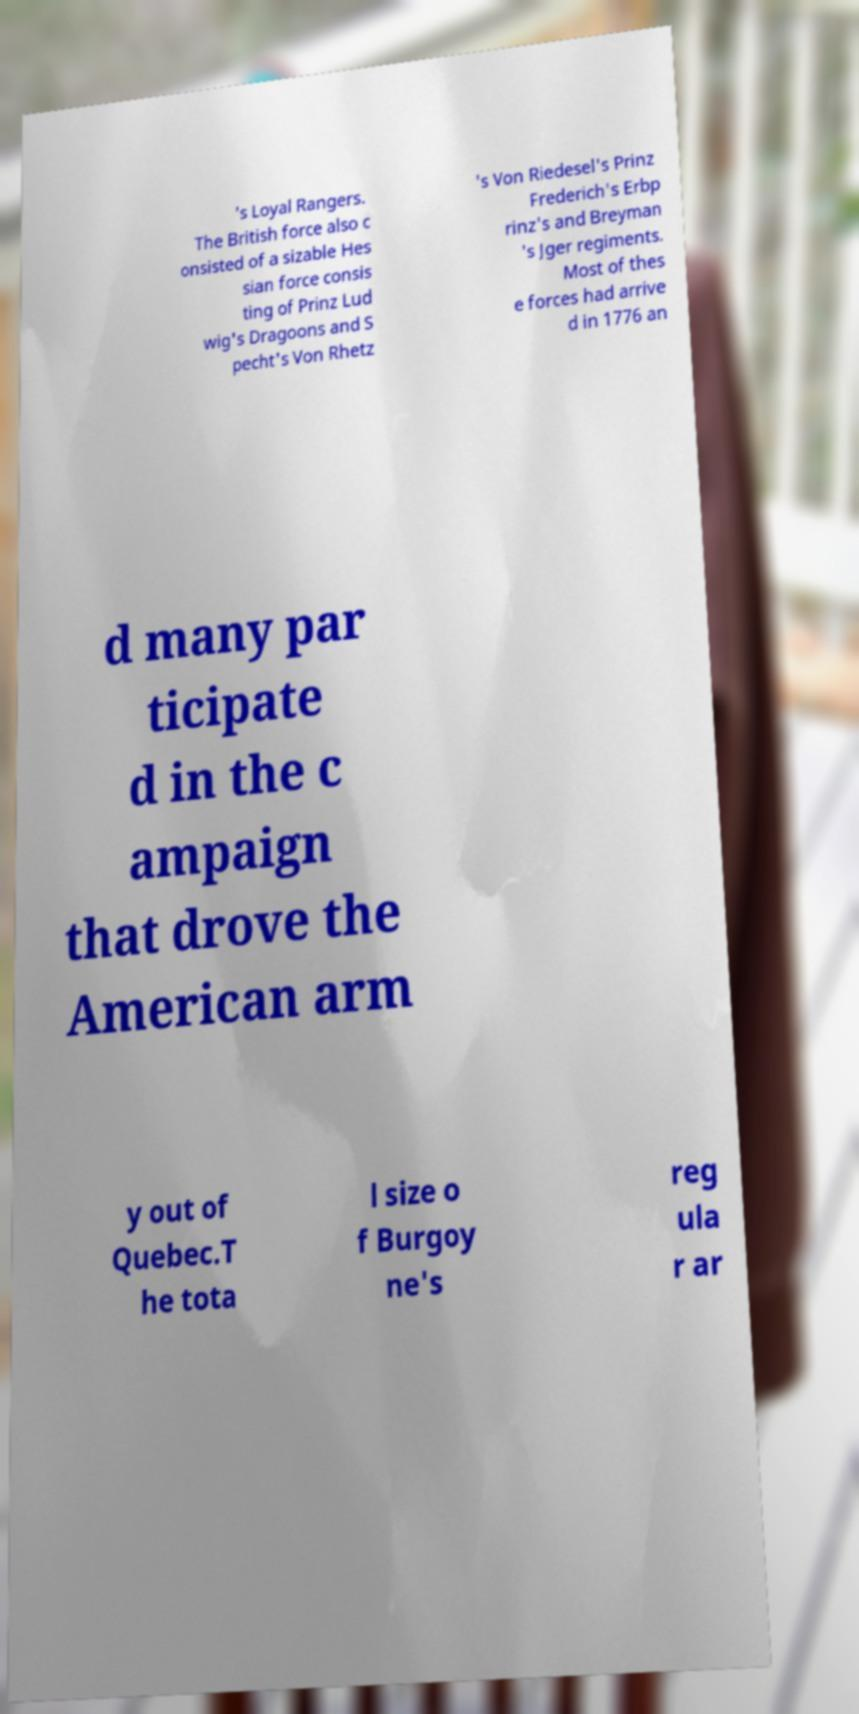There's text embedded in this image that I need extracted. Can you transcribe it verbatim? 's Loyal Rangers. The British force also c onsisted of a sizable Hes sian force consis ting of Prinz Lud wig's Dragoons and S pecht's Von Rhetz 's Von Riedesel's Prinz Frederich's Erbp rinz's and Breyman 's Jger regiments. Most of thes e forces had arrive d in 1776 an d many par ticipate d in the c ampaign that drove the American arm y out of Quebec.T he tota l size o f Burgoy ne's reg ula r ar 